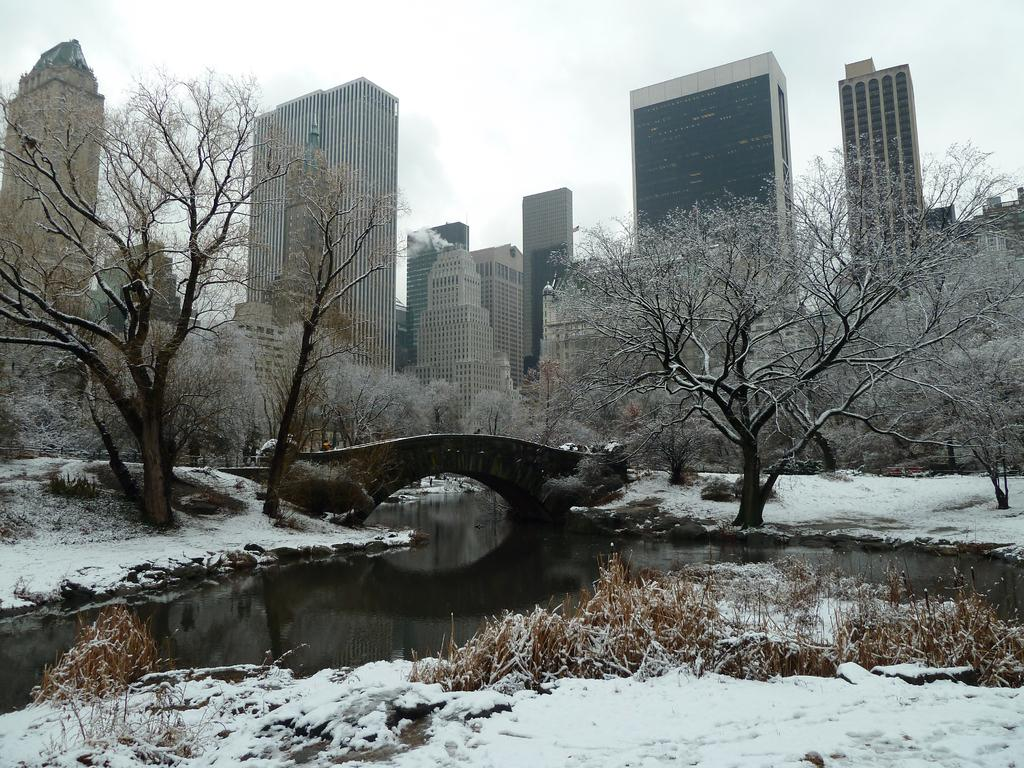What type of weather is depicted in the image? There is snow in the image, indicating cold weather. What can be seen in the water in the image? The image only shows snow, water, a bridge, buildings, trees, and the sky, but it does not provide any information about what can be seen in the water. What structure is present in the image that connects two areas? There is a bridge in the image. What type of structures can be seen in the image? There are buildings in the image. What type of vegetation is present in the image? There are trees in the image. What is visible in the background of the image? The sky is visible in the background of the image. What type of butter is being spread on the trees in the image? There is no butter present in the image; it features snow, water, a bridge, buildings, trees, and the sky. What sound can be heard coming from the buildings in the image? The image does not provide any information about sounds, so it is not possible to determine what sound might be coming from the buildings. 